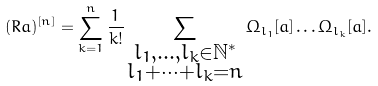Convert formula to latex. <formula><loc_0><loc_0><loc_500><loc_500>( R a ) ^ { [ n ] } = \sum _ { k = 1 } ^ { n } \frac { 1 } { k ! } \sum _ { \substack { l _ { 1 } , \dots , l _ { k } \in \mathbb { N } ^ { \ast } \\ l _ { 1 } + \cdots + l _ { k } = n } } \Omega _ { l _ { 1 } } [ a ] \dots \Omega _ { l _ { k } } [ a ] .</formula> 